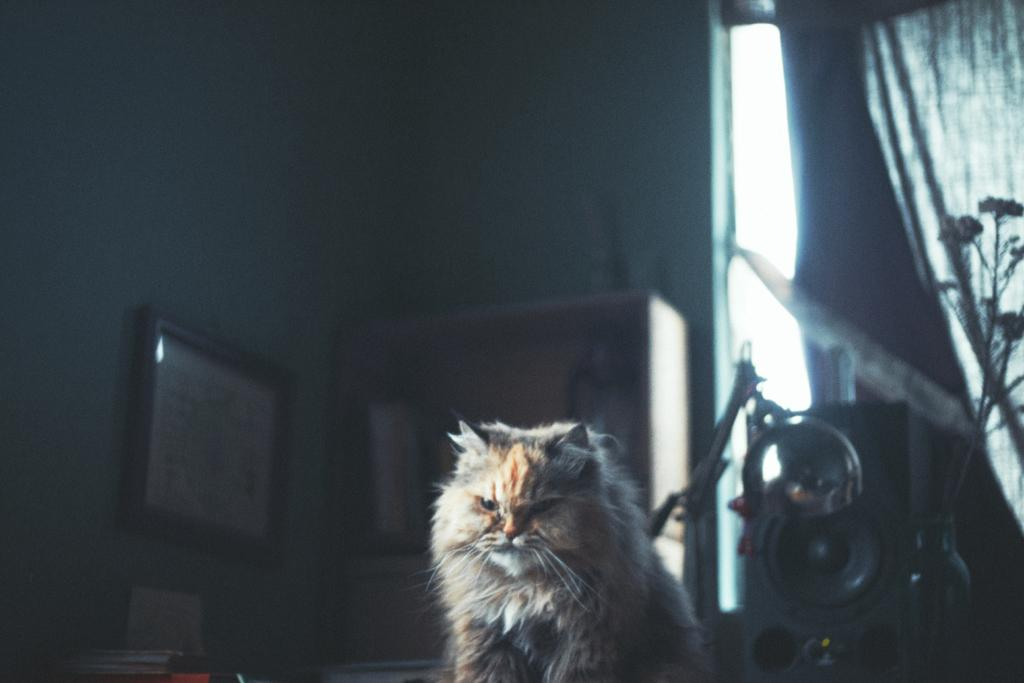What type of animal is in the image? There is a cat in the image. Where is the cat located in the image? The cat is at the bottom of the image. What color is the cat? The cat is cream-colored. What can be seen on the right side of the image? There is a plant and a curtain on the right side of the image. What sense does the cat use to detect the presence of the banana in the image? There is no banana present in the image, so the cat cannot use any sense to detect it. 